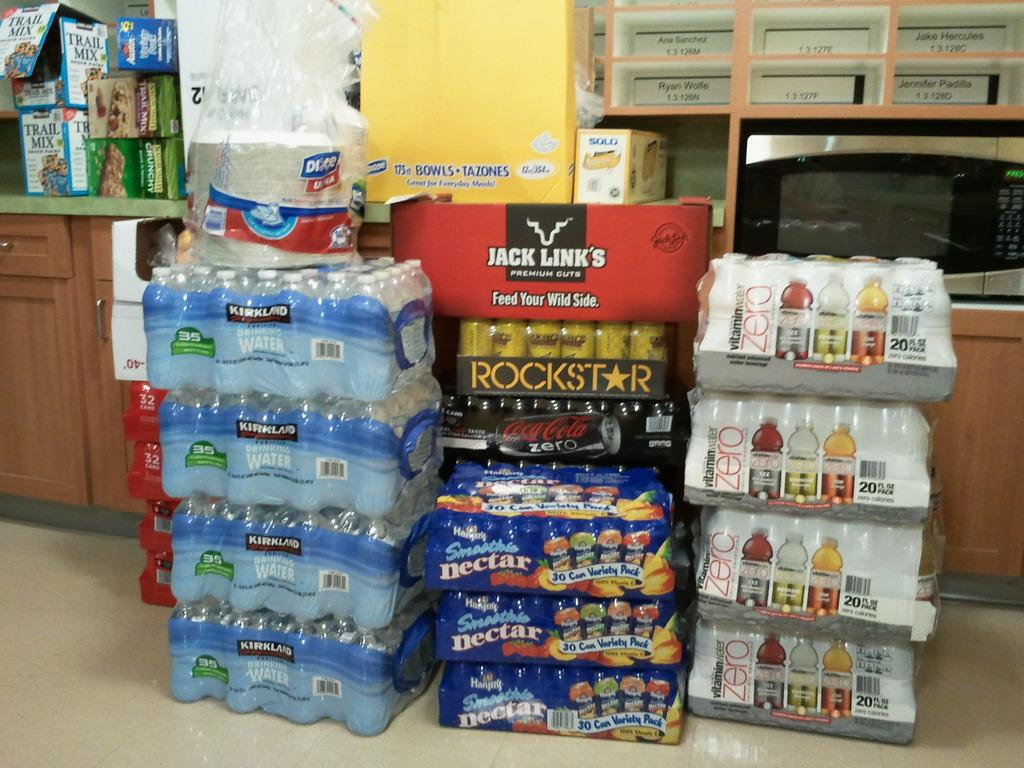Provide a one-sentence caption for the provided image. A stack of Kirkland water bottles on top of one another. 